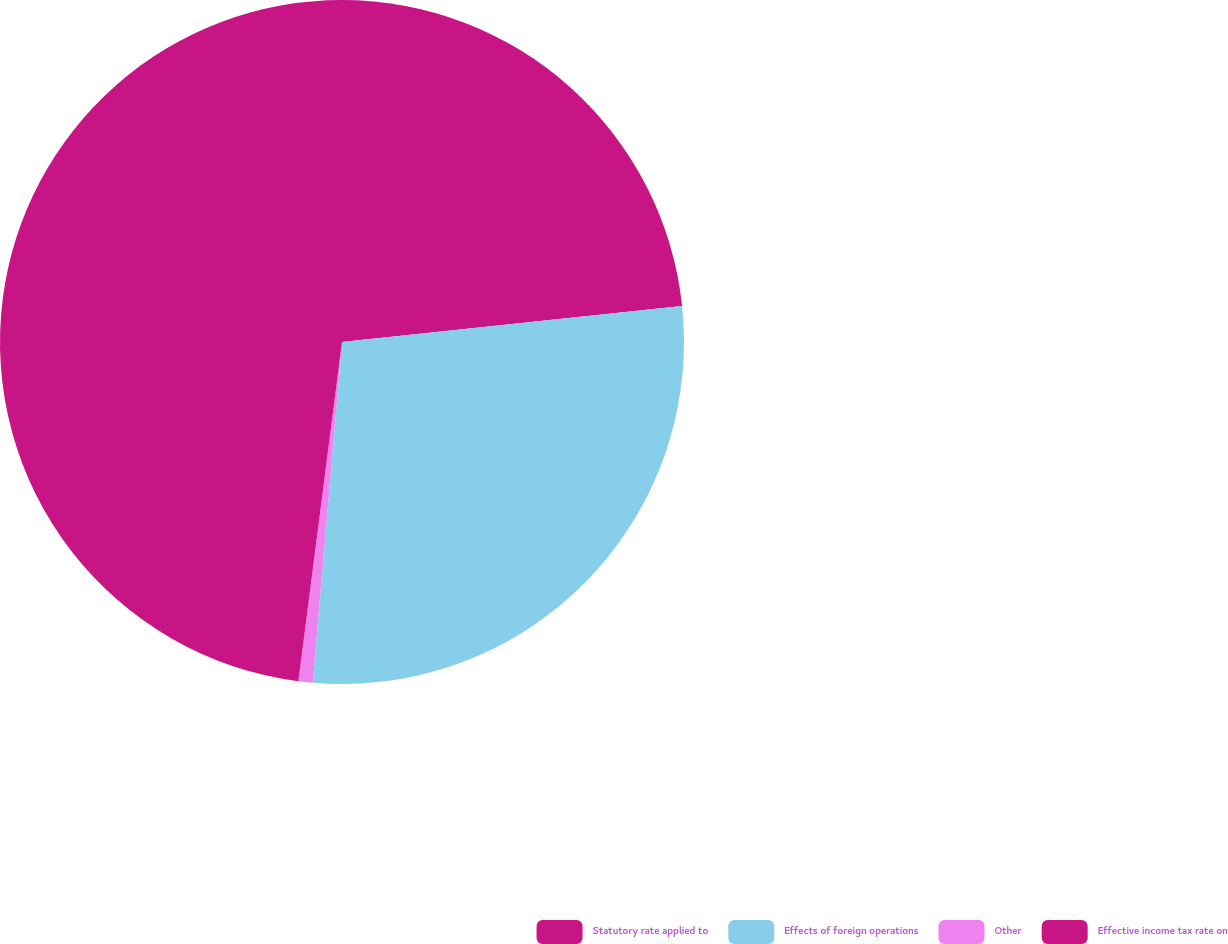Convert chart to OTSL. <chart><loc_0><loc_0><loc_500><loc_500><pie_chart><fcel>Statutory rate applied to<fcel>Effects of foreign operations<fcel>Other<fcel>Effective income tax rate on<nl><fcel>23.32%<fcel>28.05%<fcel>0.67%<fcel>47.97%<nl></chart> 